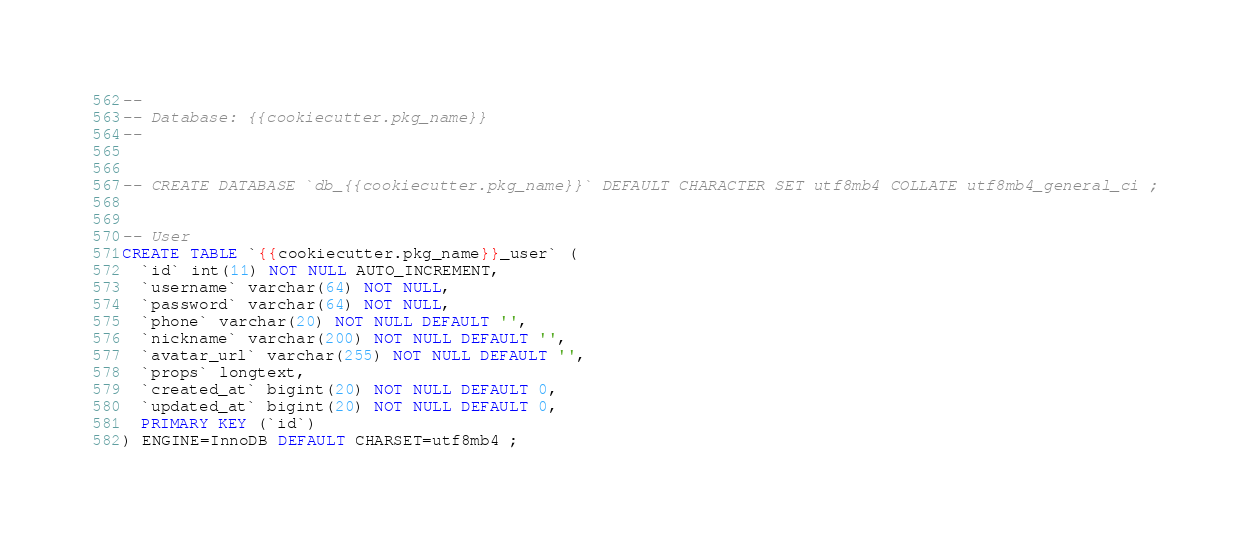<code> <loc_0><loc_0><loc_500><loc_500><_SQL_>--
-- Database: {{cookiecutter.pkg_name}}
--


-- CREATE DATABASE `db_{{cookiecutter.pkg_name}}` DEFAULT CHARACTER SET utf8mb4 COLLATE utf8mb4_general_ci ;


-- User
CREATE TABLE `{{cookiecutter.pkg_name}}_user` (
  `id` int(11) NOT NULL AUTO_INCREMENT,
  `username` varchar(64) NOT NULL,
  `password` varchar(64) NOT NULL,
  `phone` varchar(20) NOT NULL DEFAULT '',
  `nickname` varchar(200) NOT NULL DEFAULT '',
  `avatar_url` varchar(255) NOT NULL DEFAULT '',
  `props` longtext,
  `created_at` bigint(20) NOT NULL DEFAULT 0,
  `updated_at` bigint(20) NOT NULL DEFAULT 0,
  PRIMARY KEY (`id`)
) ENGINE=InnoDB DEFAULT CHARSET=utf8mb4 ;
</code> 